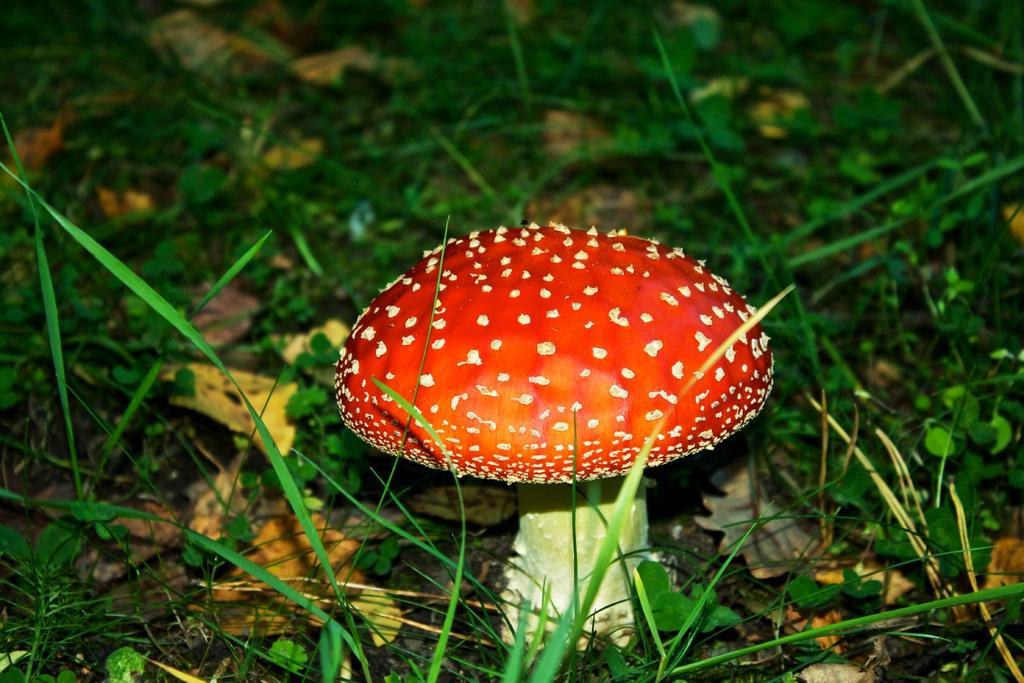Could you give a brief overview of what you see in this image? In this picture we can see a mushroom on the ground and in the background we can see grass. 